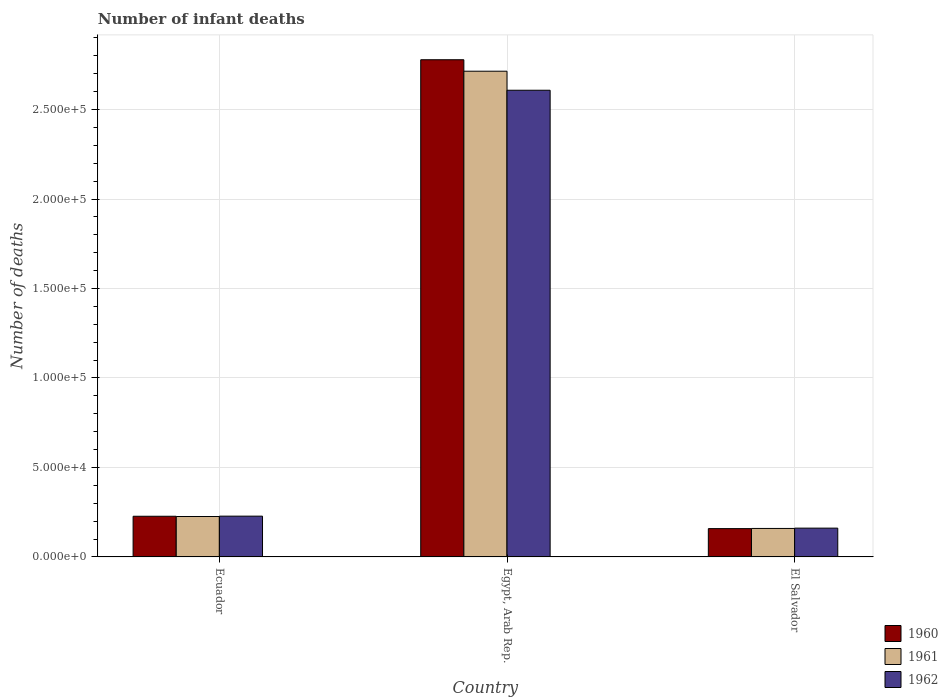How many bars are there on the 2nd tick from the left?
Ensure brevity in your answer.  3. How many bars are there on the 1st tick from the right?
Your answer should be compact. 3. What is the label of the 1st group of bars from the left?
Give a very brief answer. Ecuador. What is the number of infant deaths in 1960 in Ecuador?
Your answer should be very brief. 2.27e+04. Across all countries, what is the maximum number of infant deaths in 1960?
Your answer should be compact. 2.78e+05. Across all countries, what is the minimum number of infant deaths in 1961?
Give a very brief answer. 1.59e+04. In which country was the number of infant deaths in 1960 maximum?
Provide a short and direct response. Egypt, Arab Rep. In which country was the number of infant deaths in 1962 minimum?
Ensure brevity in your answer.  El Salvador. What is the total number of infant deaths in 1961 in the graph?
Ensure brevity in your answer.  3.10e+05. What is the difference between the number of infant deaths in 1962 in Ecuador and that in El Salvador?
Offer a very short reply. 6700. What is the difference between the number of infant deaths in 1962 in El Salvador and the number of infant deaths in 1961 in Egypt, Arab Rep.?
Keep it short and to the point. -2.55e+05. What is the average number of infant deaths in 1960 per country?
Offer a terse response. 1.05e+05. What is the difference between the number of infant deaths of/in 1961 and number of infant deaths of/in 1962 in Egypt, Arab Rep.?
Ensure brevity in your answer.  1.06e+04. What is the ratio of the number of infant deaths in 1962 in Ecuador to that in Egypt, Arab Rep.?
Your answer should be very brief. 0.09. What is the difference between the highest and the second highest number of infant deaths in 1960?
Keep it short and to the point. -2.55e+05. What is the difference between the highest and the lowest number of infant deaths in 1962?
Offer a very short reply. 2.45e+05. What does the 3rd bar from the right in Egypt, Arab Rep. represents?
Offer a terse response. 1960. Is it the case that in every country, the sum of the number of infant deaths in 1962 and number of infant deaths in 1961 is greater than the number of infant deaths in 1960?
Offer a very short reply. Yes. Are the values on the major ticks of Y-axis written in scientific E-notation?
Provide a short and direct response. Yes. Where does the legend appear in the graph?
Your response must be concise. Bottom right. How many legend labels are there?
Offer a terse response. 3. What is the title of the graph?
Offer a very short reply. Number of infant deaths. What is the label or title of the Y-axis?
Your answer should be compact. Number of deaths. What is the Number of deaths in 1960 in Ecuador?
Make the answer very short. 2.27e+04. What is the Number of deaths of 1961 in Ecuador?
Give a very brief answer. 2.26e+04. What is the Number of deaths of 1962 in Ecuador?
Offer a terse response. 2.28e+04. What is the Number of deaths of 1960 in Egypt, Arab Rep.?
Make the answer very short. 2.78e+05. What is the Number of deaths in 1961 in Egypt, Arab Rep.?
Your answer should be very brief. 2.71e+05. What is the Number of deaths of 1962 in Egypt, Arab Rep.?
Provide a succinct answer. 2.61e+05. What is the Number of deaths of 1960 in El Salvador?
Make the answer very short. 1.58e+04. What is the Number of deaths in 1961 in El Salvador?
Ensure brevity in your answer.  1.59e+04. What is the Number of deaths of 1962 in El Salvador?
Offer a terse response. 1.61e+04. Across all countries, what is the maximum Number of deaths of 1960?
Provide a short and direct response. 2.78e+05. Across all countries, what is the maximum Number of deaths of 1961?
Your answer should be very brief. 2.71e+05. Across all countries, what is the maximum Number of deaths of 1962?
Ensure brevity in your answer.  2.61e+05. Across all countries, what is the minimum Number of deaths of 1960?
Offer a terse response. 1.58e+04. Across all countries, what is the minimum Number of deaths in 1961?
Your answer should be very brief. 1.59e+04. Across all countries, what is the minimum Number of deaths in 1962?
Offer a terse response. 1.61e+04. What is the total Number of deaths in 1960 in the graph?
Keep it short and to the point. 3.16e+05. What is the total Number of deaths in 1961 in the graph?
Provide a succinct answer. 3.10e+05. What is the total Number of deaths in 1962 in the graph?
Provide a succinct answer. 3.00e+05. What is the difference between the Number of deaths of 1960 in Ecuador and that in Egypt, Arab Rep.?
Keep it short and to the point. -2.55e+05. What is the difference between the Number of deaths in 1961 in Ecuador and that in Egypt, Arab Rep.?
Ensure brevity in your answer.  -2.49e+05. What is the difference between the Number of deaths in 1962 in Ecuador and that in Egypt, Arab Rep.?
Make the answer very short. -2.38e+05. What is the difference between the Number of deaths of 1960 in Ecuador and that in El Salvador?
Your response must be concise. 6912. What is the difference between the Number of deaths of 1961 in Ecuador and that in El Salvador?
Offer a terse response. 6672. What is the difference between the Number of deaths in 1962 in Ecuador and that in El Salvador?
Keep it short and to the point. 6700. What is the difference between the Number of deaths in 1960 in Egypt, Arab Rep. and that in El Salvador?
Your answer should be compact. 2.62e+05. What is the difference between the Number of deaths in 1961 in Egypt, Arab Rep. and that in El Salvador?
Provide a short and direct response. 2.56e+05. What is the difference between the Number of deaths in 1962 in Egypt, Arab Rep. and that in El Salvador?
Your answer should be very brief. 2.45e+05. What is the difference between the Number of deaths in 1960 in Ecuador and the Number of deaths in 1961 in Egypt, Arab Rep.?
Make the answer very short. -2.49e+05. What is the difference between the Number of deaths of 1960 in Ecuador and the Number of deaths of 1962 in Egypt, Arab Rep.?
Give a very brief answer. -2.38e+05. What is the difference between the Number of deaths of 1961 in Ecuador and the Number of deaths of 1962 in Egypt, Arab Rep.?
Your answer should be compact. -2.38e+05. What is the difference between the Number of deaths in 1960 in Ecuador and the Number of deaths in 1961 in El Salvador?
Your response must be concise. 6815. What is the difference between the Number of deaths of 1960 in Ecuador and the Number of deaths of 1962 in El Salvador?
Provide a succinct answer. 6641. What is the difference between the Number of deaths of 1961 in Ecuador and the Number of deaths of 1962 in El Salvador?
Your answer should be very brief. 6498. What is the difference between the Number of deaths of 1960 in Egypt, Arab Rep. and the Number of deaths of 1961 in El Salvador?
Your answer should be compact. 2.62e+05. What is the difference between the Number of deaths in 1960 in Egypt, Arab Rep. and the Number of deaths in 1962 in El Salvador?
Your answer should be compact. 2.62e+05. What is the difference between the Number of deaths in 1961 in Egypt, Arab Rep. and the Number of deaths in 1962 in El Salvador?
Your answer should be very brief. 2.55e+05. What is the average Number of deaths of 1960 per country?
Your answer should be very brief. 1.05e+05. What is the average Number of deaths of 1961 per country?
Your answer should be compact. 1.03e+05. What is the average Number of deaths in 1962 per country?
Provide a succinct answer. 9.99e+04. What is the difference between the Number of deaths in 1960 and Number of deaths in 1961 in Ecuador?
Provide a succinct answer. 143. What is the difference between the Number of deaths in 1960 and Number of deaths in 1962 in Ecuador?
Make the answer very short. -59. What is the difference between the Number of deaths of 1961 and Number of deaths of 1962 in Ecuador?
Your answer should be very brief. -202. What is the difference between the Number of deaths of 1960 and Number of deaths of 1961 in Egypt, Arab Rep.?
Ensure brevity in your answer.  6414. What is the difference between the Number of deaths of 1960 and Number of deaths of 1962 in Egypt, Arab Rep.?
Your answer should be very brief. 1.70e+04. What is the difference between the Number of deaths of 1961 and Number of deaths of 1962 in Egypt, Arab Rep.?
Make the answer very short. 1.06e+04. What is the difference between the Number of deaths in 1960 and Number of deaths in 1961 in El Salvador?
Your answer should be compact. -97. What is the difference between the Number of deaths of 1960 and Number of deaths of 1962 in El Salvador?
Ensure brevity in your answer.  -271. What is the difference between the Number of deaths in 1961 and Number of deaths in 1962 in El Salvador?
Your answer should be very brief. -174. What is the ratio of the Number of deaths of 1960 in Ecuador to that in Egypt, Arab Rep.?
Your answer should be compact. 0.08. What is the ratio of the Number of deaths of 1961 in Ecuador to that in Egypt, Arab Rep.?
Your response must be concise. 0.08. What is the ratio of the Number of deaths in 1962 in Ecuador to that in Egypt, Arab Rep.?
Make the answer very short. 0.09. What is the ratio of the Number of deaths of 1960 in Ecuador to that in El Salvador?
Provide a short and direct response. 1.44. What is the ratio of the Number of deaths in 1961 in Ecuador to that in El Salvador?
Offer a very short reply. 1.42. What is the ratio of the Number of deaths of 1962 in Ecuador to that in El Salvador?
Your answer should be very brief. 1.42. What is the ratio of the Number of deaths of 1960 in Egypt, Arab Rep. to that in El Salvador?
Your answer should be compact. 17.56. What is the ratio of the Number of deaths of 1961 in Egypt, Arab Rep. to that in El Salvador?
Your response must be concise. 17.05. What is the ratio of the Number of deaths of 1962 in Egypt, Arab Rep. to that in El Salvador?
Give a very brief answer. 16.21. What is the difference between the highest and the second highest Number of deaths in 1960?
Offer a terse response. 2.55e+05. What is the difference between the highest and the second highest Number of deaths in 1961?
Make the answer very short. 2.49e+05. What is the difference between the highest and the second highest Number of deaths in 1962?
Your answer should be compact. 2.38e+05. What is the difference between the highest and the lowest Number of deaths in 1960?
Offer a very short reply. 2.62e+05. What is the difference between the highest and the lowest Number of deaths of 1961?
Your response must be concise. 2.56e+05. What is the difference between the highest and the lowest Number of deaths of 1962?
Your answer should be compact. 2.45e+05. 